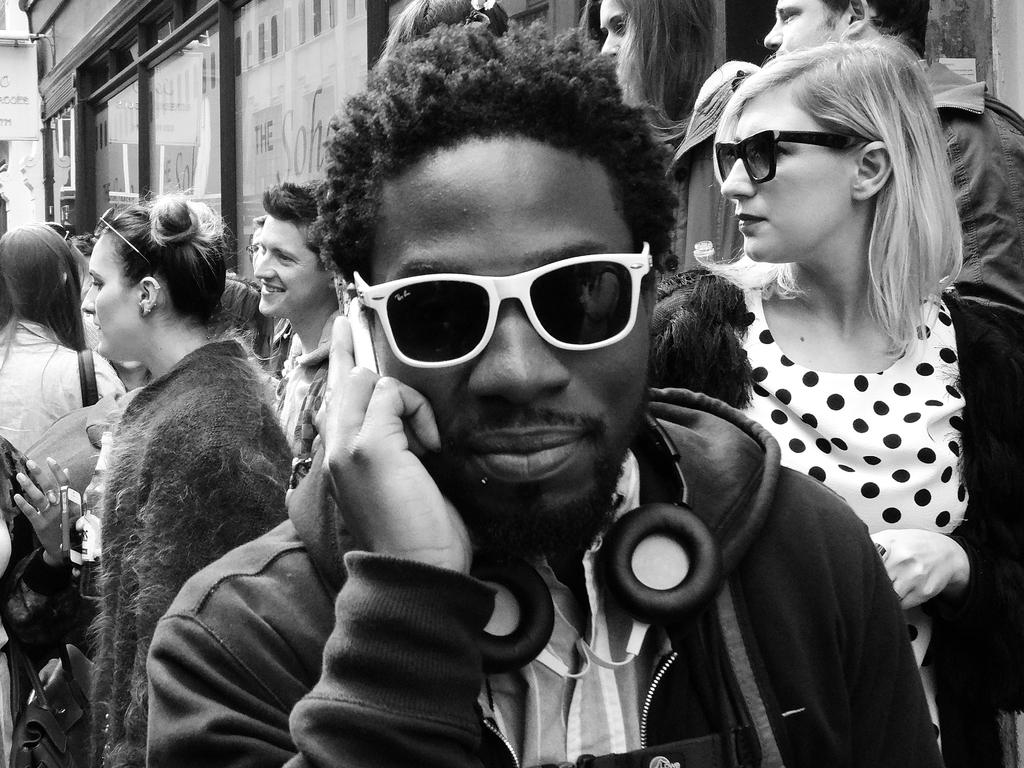What is the color scheme of the image? The image is black and white. What can be seen in the background of the image? There are people standing near a store. Who is the main subject in the front of the image? There is a man in the front of the image. What is the man wearing? The man is wearing a headset. What is the man holding in the image? The man is holding a mobile phone. What is the grandfather's wish in the image? There is no grandfather present in the image, so it is not possible to determine his wish. 